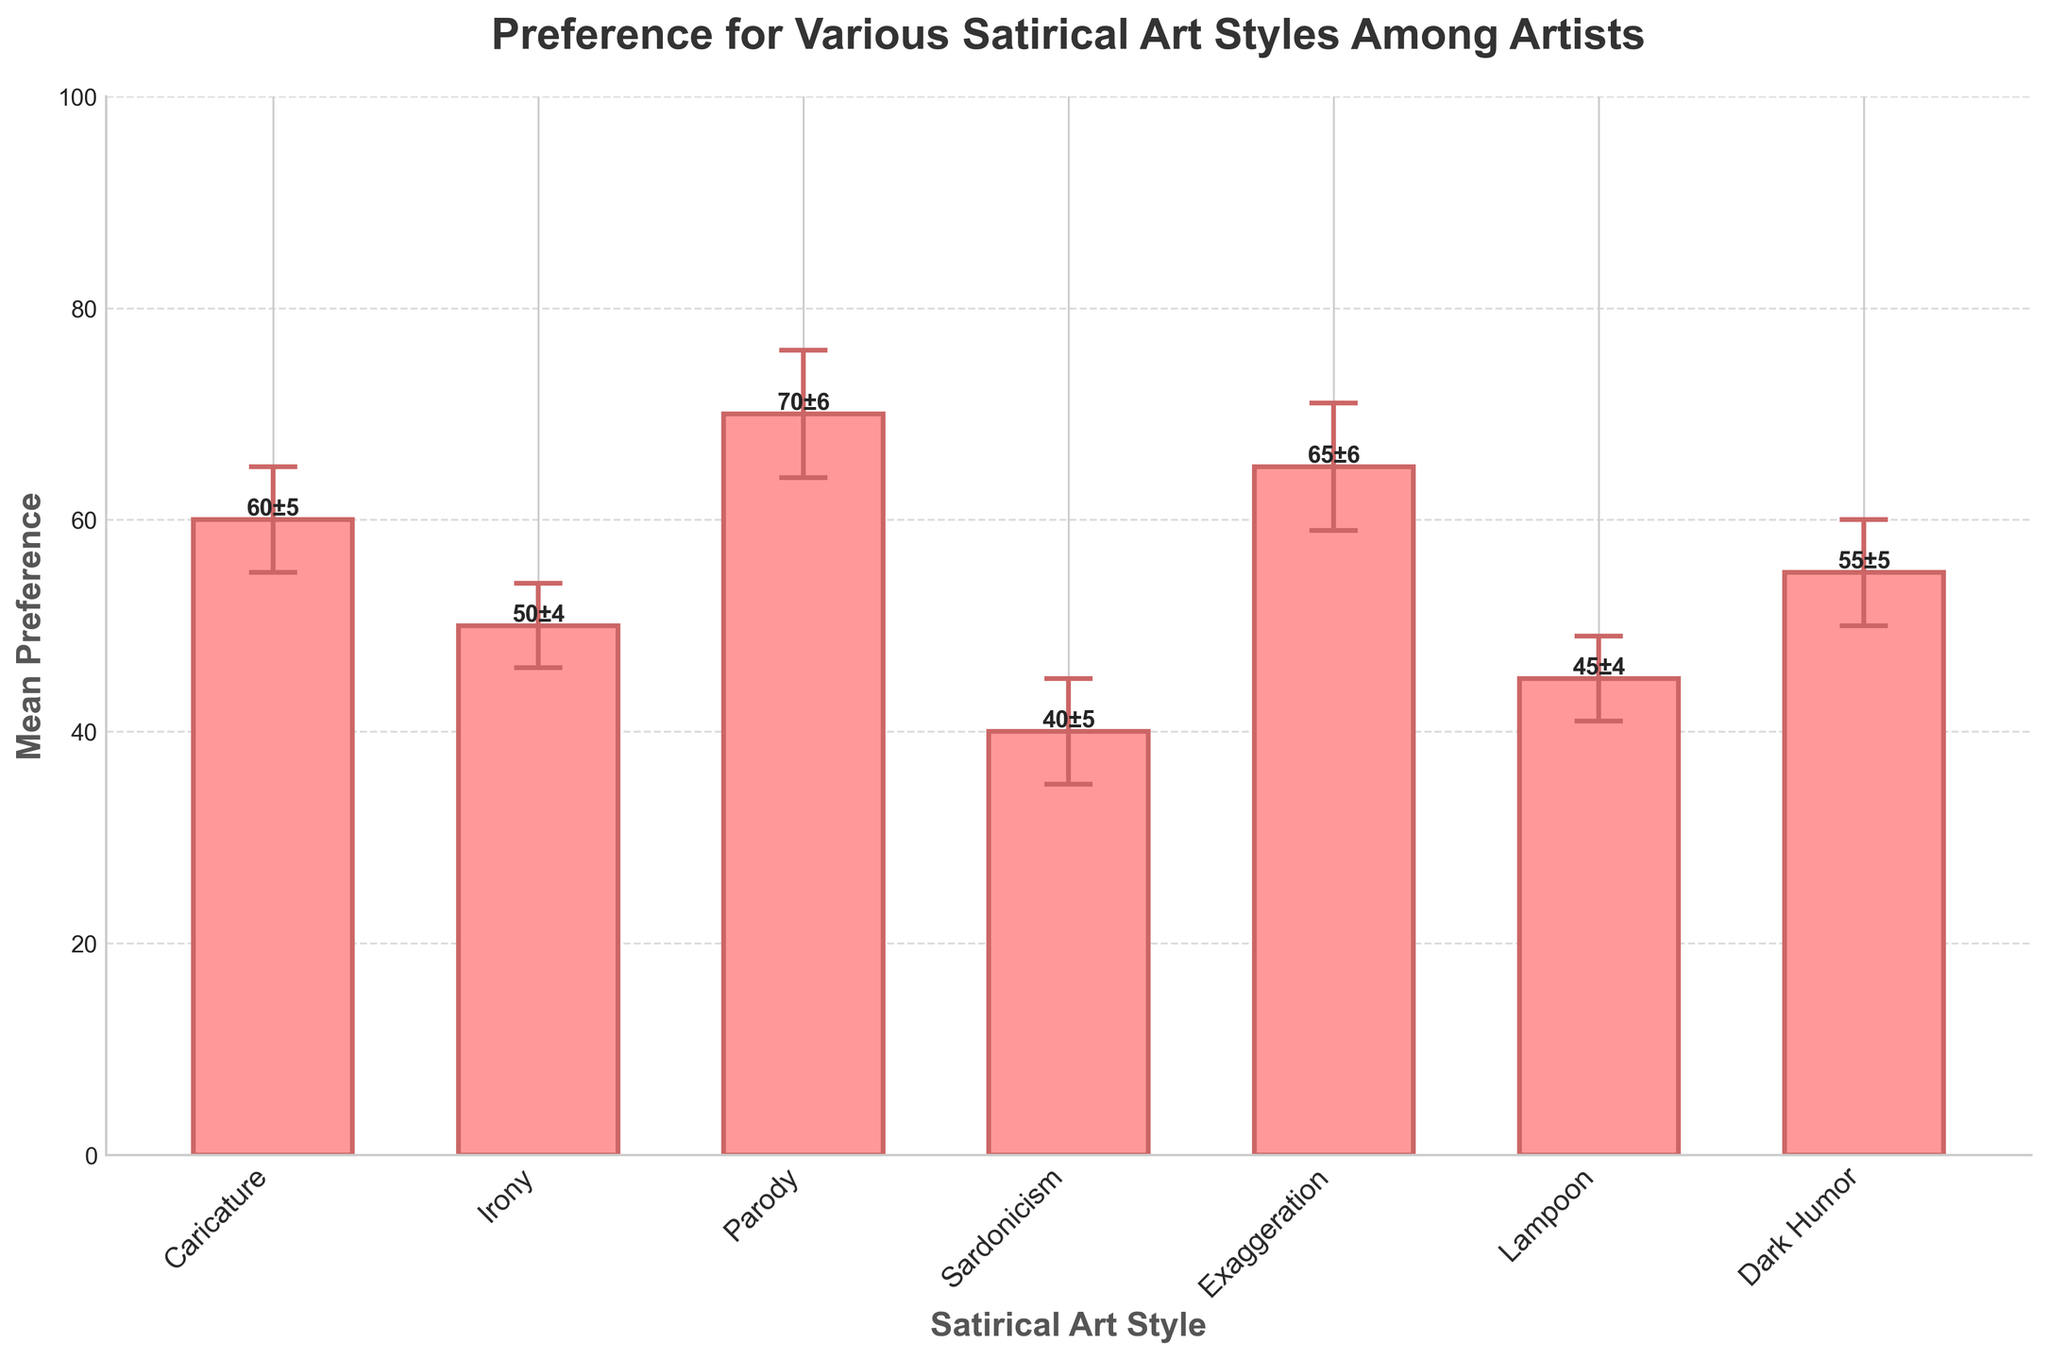What is the title of the figure? The title of the figure is displayed at the top and reads "Preference for Various Satirical Art Styles Among Artists."
Answer: Preference for Various Satirical Art Styles Among Artists What is the mean preference for Exaggeration? The mean preference for Exaggeration is found by looking at the height of the bar labeled "Exaggeration" and the text above it, which shows "65±6"
Answer: 65 What are the error margins for each satirical art style? The error margins are shown as the sizes of the caps on the error bars, with the numerical values also written above each bar: Caricature (5), Irony (4), Parody (6), Sardonicism (5), Exaggeration (6), Lampoon (4), Dark Humor (5).
Answer: Caricature (5), Irony (4), Parody (6), Sardonicism (5), Exaggeration (6), Lampoon (4), Dark Humor (5) Which satirical art style has the highest mean preference? The satirical art style with the highest mean preference can be found by comparing the heights of the bars. Parody has the highest bar, and the text above it shows "70±6".
Answer: Parody How many different satirical art styles are represented in the figure? The number of different satirical art styles is represented by the number of bars in the chart. There are 7 bars.
Answer: 7 What is the mean preference difference between Caricature and Sardonicism? The mean preference for Caricature is 60 and for Sardonicism is 40. Subtracting these values gives the difference: 60 - 40 = 20
Answer: 20 Which two satirical art styles have the lowest mean preferences? The styles with the lowest mean preferences are found by comparing the bar heights. Sardonicism (40) and Lampoon (45) have the lowest heights.
Answer: Sardonicism and Lampoon Calculate the average mean preference across all satirical art styles. Sum the mean preferences of all styles and divide by the number of styles. (60 + 50 + 70 + 40 + 65 + 45 + 55) / 7 = 385 / 7 ≈ 55
Answer: 55 Which satirical art styles have an error margin greater than 5? By analyzing the error margins written above each bar: Parody (6) and Exaggeration (6) both have error margins greater than 5.
Answer: Parody and Exaggeration 